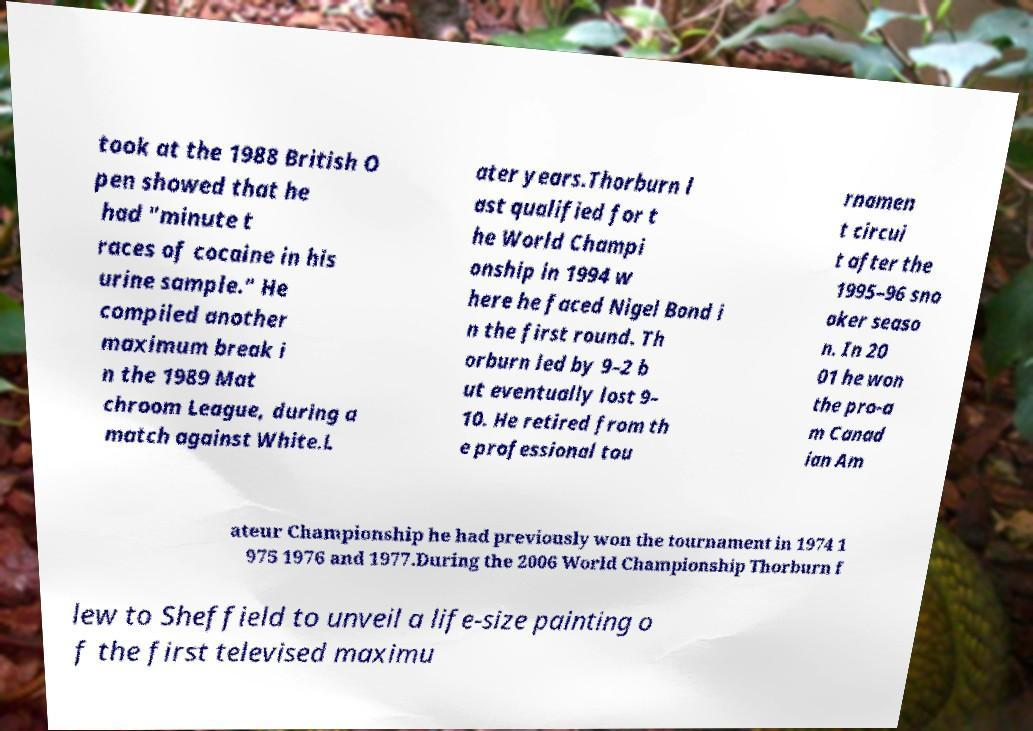There's text embedded in this image that I need extracted. Can you transcribe it verbatim? took at the 1988 British O pen showed that he had "minute t races of cocaine in his urine sample." He compiled another maximum break i n the 1989 Mat chroom League, during a match against White.L ater years.Thorburn l ast qualified for t he World Champi onship in 1994 w here he faced Nigel Bond i n the first round. Th orburn led by 9–2 b ut eventually lost 9– 10. He retired from th e professional tou rnamen t circui t after the 1995–96 sno oker seaso n. In 20 01 he won the pro-a m Canad ian Am ateur Championship he had previously won the tournament in 1974 1 975 1976 and 1977.During the 2006 World Championship Thorburn f lew to Sheffield to unveil a life-size painting o f the first televised maximu 